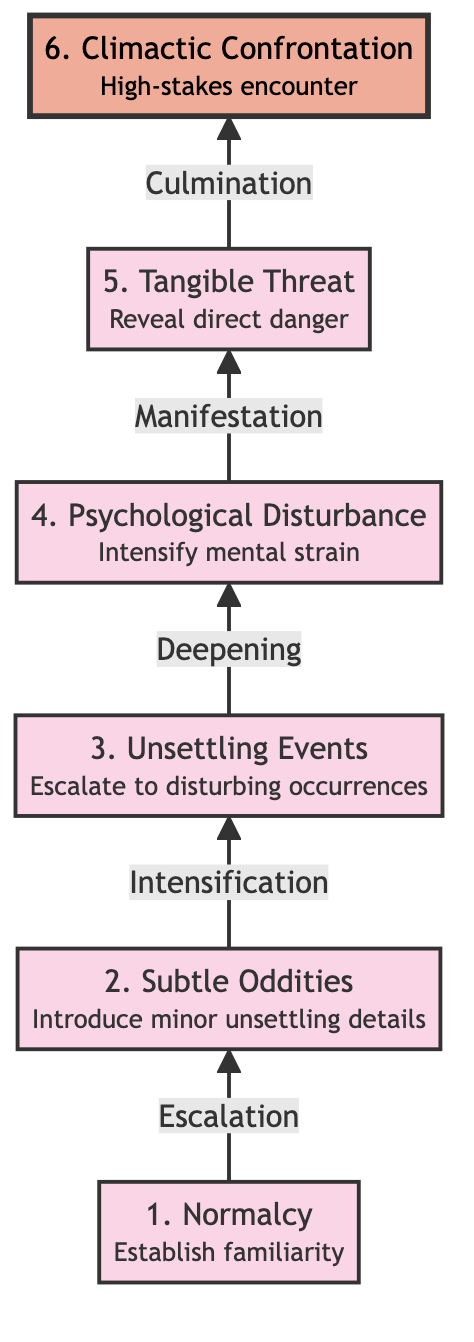What is the highest level in the diagram? The highest level in the diagram is "Climactic Confrontation," which is at level 6.
Answer: Climactic Confrontation How many nodes are present in the diagram? There are six nodes, including Normalcy, Subtle Oddities, Unsettling Events, Psychological Disturbance, Tangible Threat, and Climactic Confrontation.
Answer: Six What follows "Subtle Oddities" in the sequence? The next step following "Subtle Oddities" is "Unsettling Events."
Answer: Unsettling Events Which node intensifies the mental strain? The node that intensifies the mental strain is "Psychological Disturbance."
Answer: Psychological Disturbance What characterizes the last node? The last node, "Climactic Confrontation," is characterized as a high-stakes encounter.
Answer: High-stakes encounter What is the direct relationship between "Psychological Disturbance" and "Tangible Threat"? "Psychological Disturbance" leads to "Tangible Threat," indicating a progression toward revealing a physical danger.
Answer: Leads to What is the transition from "Unsettling Events" to "Psychological Disturbance"? The transition from "Unsettling Events" to "Psychological Disturbance" is described as "Deepening," which emphasizes an increase in psychological tension.
Answer: Deepening Which node indicates the manifestation of a direct danger? The node that indicates the manifestation of a direct danger is "Tangible Threat."
Answer: Tangible Threat What is the direction of the flow in the diagram? The flow in the diagram moves from the bottom to the top, indicating a progression from subtle hints to full-blown dread.
Answer: Bottom to top 